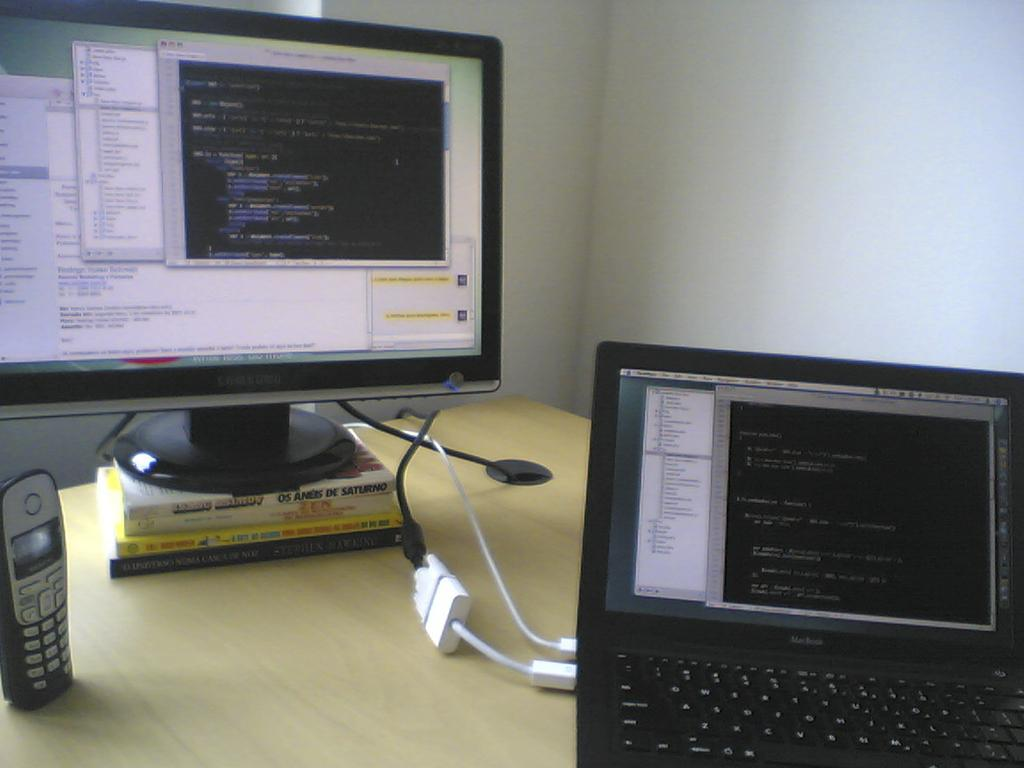What piece of furniture is present in the image? There is a table in the image. What electronic device can be seen on the table? There is a mobile phone on the table. What other electronic devices are on the table? There are monitors and a laptop on the table. What can be seen in the background of the image? There is a wall visible in the background of the image. What type of nut is being cracked on the table in the image? There is no nut present in the image; the table contains electronic devices such as a mobile phone, monitors, and a laptop. What kind of linen is draped over the laptop in the image? There is no linen present in the image; the laptop is not covered by any fabric. 